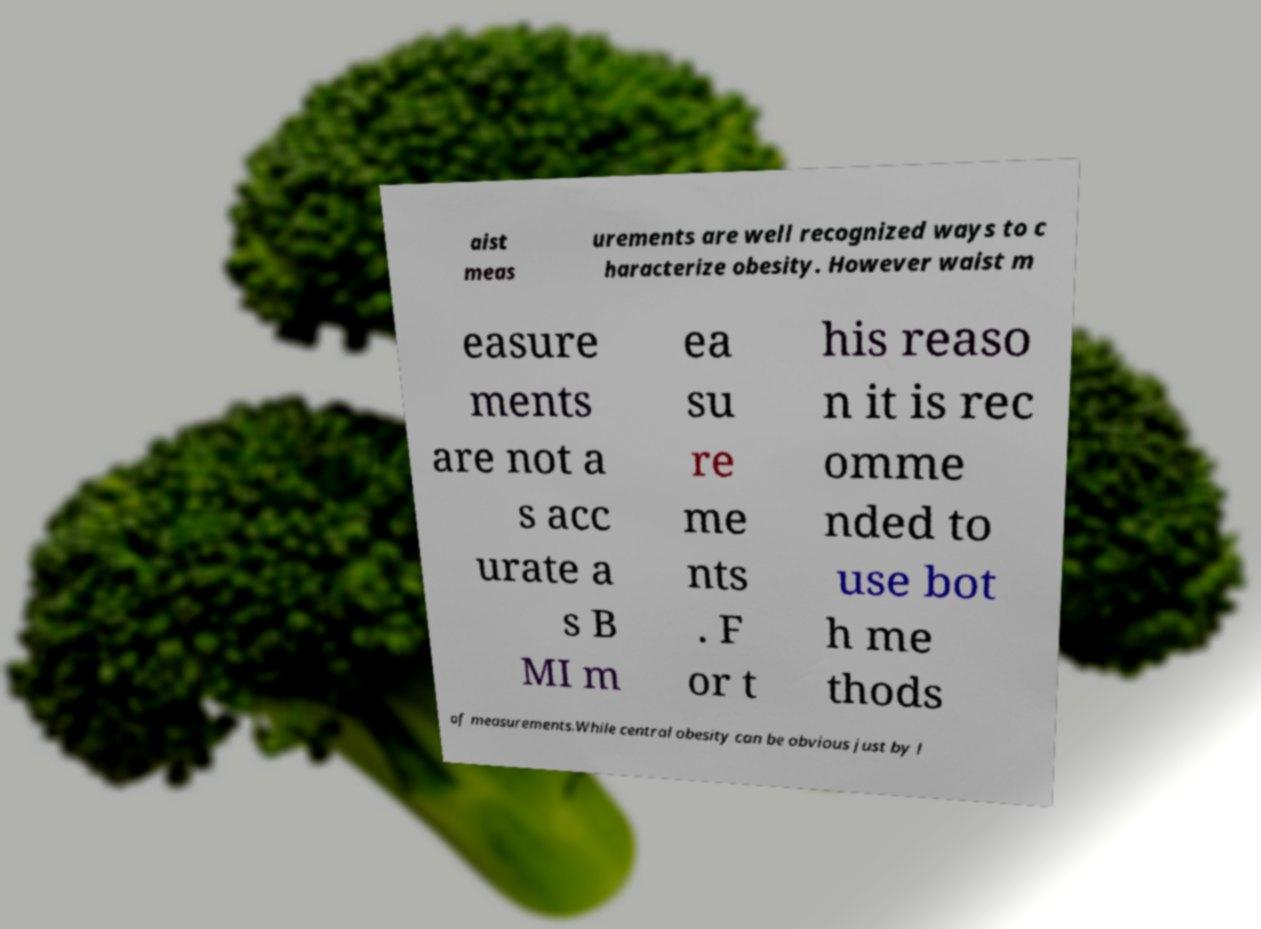What messages or text are displayed in this image? I need them in a readable, typed format. aist meas urements are well recognized ways to c haracterize obesity. However waist m easure ments are not a s acc urate a s B MI m ea su re me nts . F or t his reaso n it is rec omme nded to use bot h me thods of measurements.While central obesity can be obvious just by l 